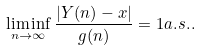Convert formula to latex. <formula><loc_0><loc_0><loc_500><loc_500>\liminf _ { n \to \infty } \frac { | Y ( n ) - x | } { g ( n ) } = 1 a . s . .</formula> 